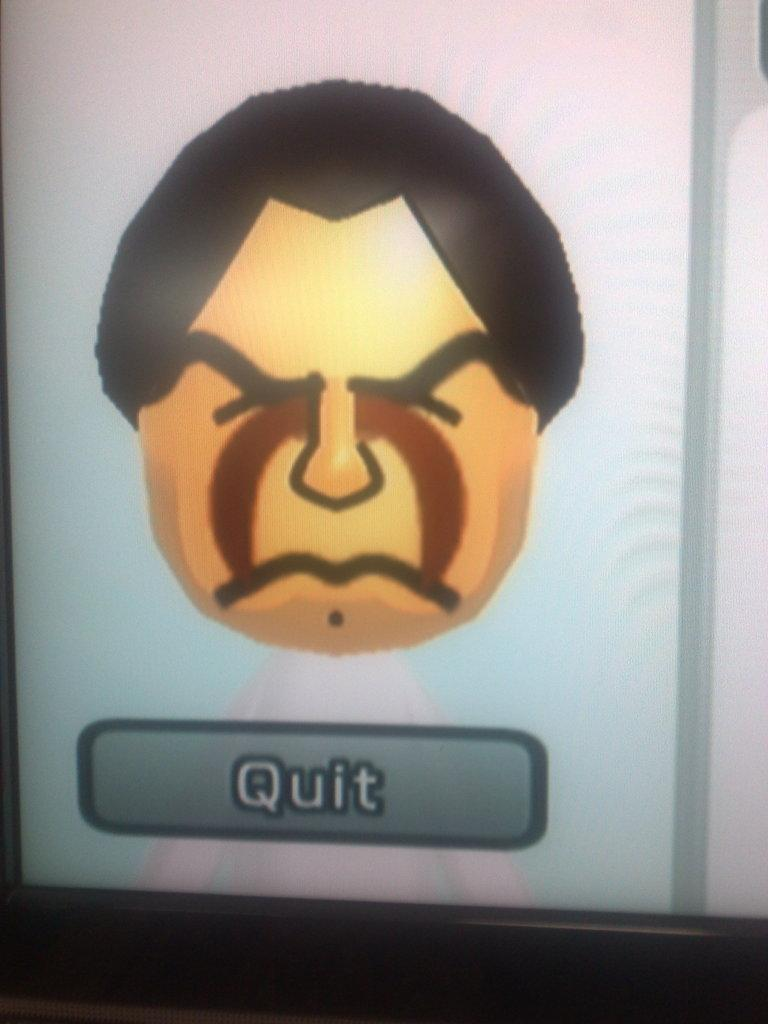What is displayed on the screen in the image? There is an animated image of a person on the screen. What else can be seen on the screen besides the animated person? There is a button on the screen. What is the color of the background in the image? The background color is white. What type of dinner is being prepared in the image? There is no dinner or any indication of food preparation in the image; it features an animated person and a button on a white background. 